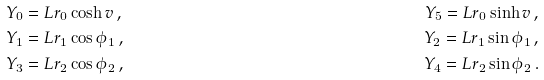<formula> <loc_0><loc_0><loc_500><loc_500>& Y _ { 0 } = L r _ { 0 } \cosh v \, , \quad & Y _ { 5 } = L r _ { 0 } \sinh v \, , \\ & Y _ { 1 } = L r _ { 1 } \cos \phi _ { 1 } \, , \quad & Y _ { 2 } = L r _ { 1 } \sin \phi _ { 1 } \, , \\ & Y _ { 3 } = L r _ { 2 } \cos \phi _ { 2 } \, , \quad & Y _ { 4 } = L r _ { 2 } \sin \phi _ { 2 } \, .</formula> 